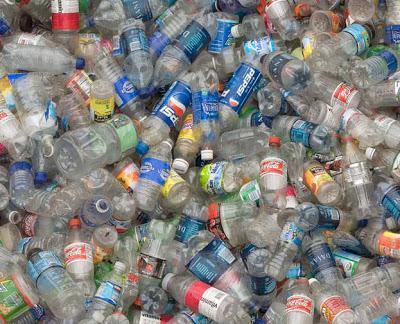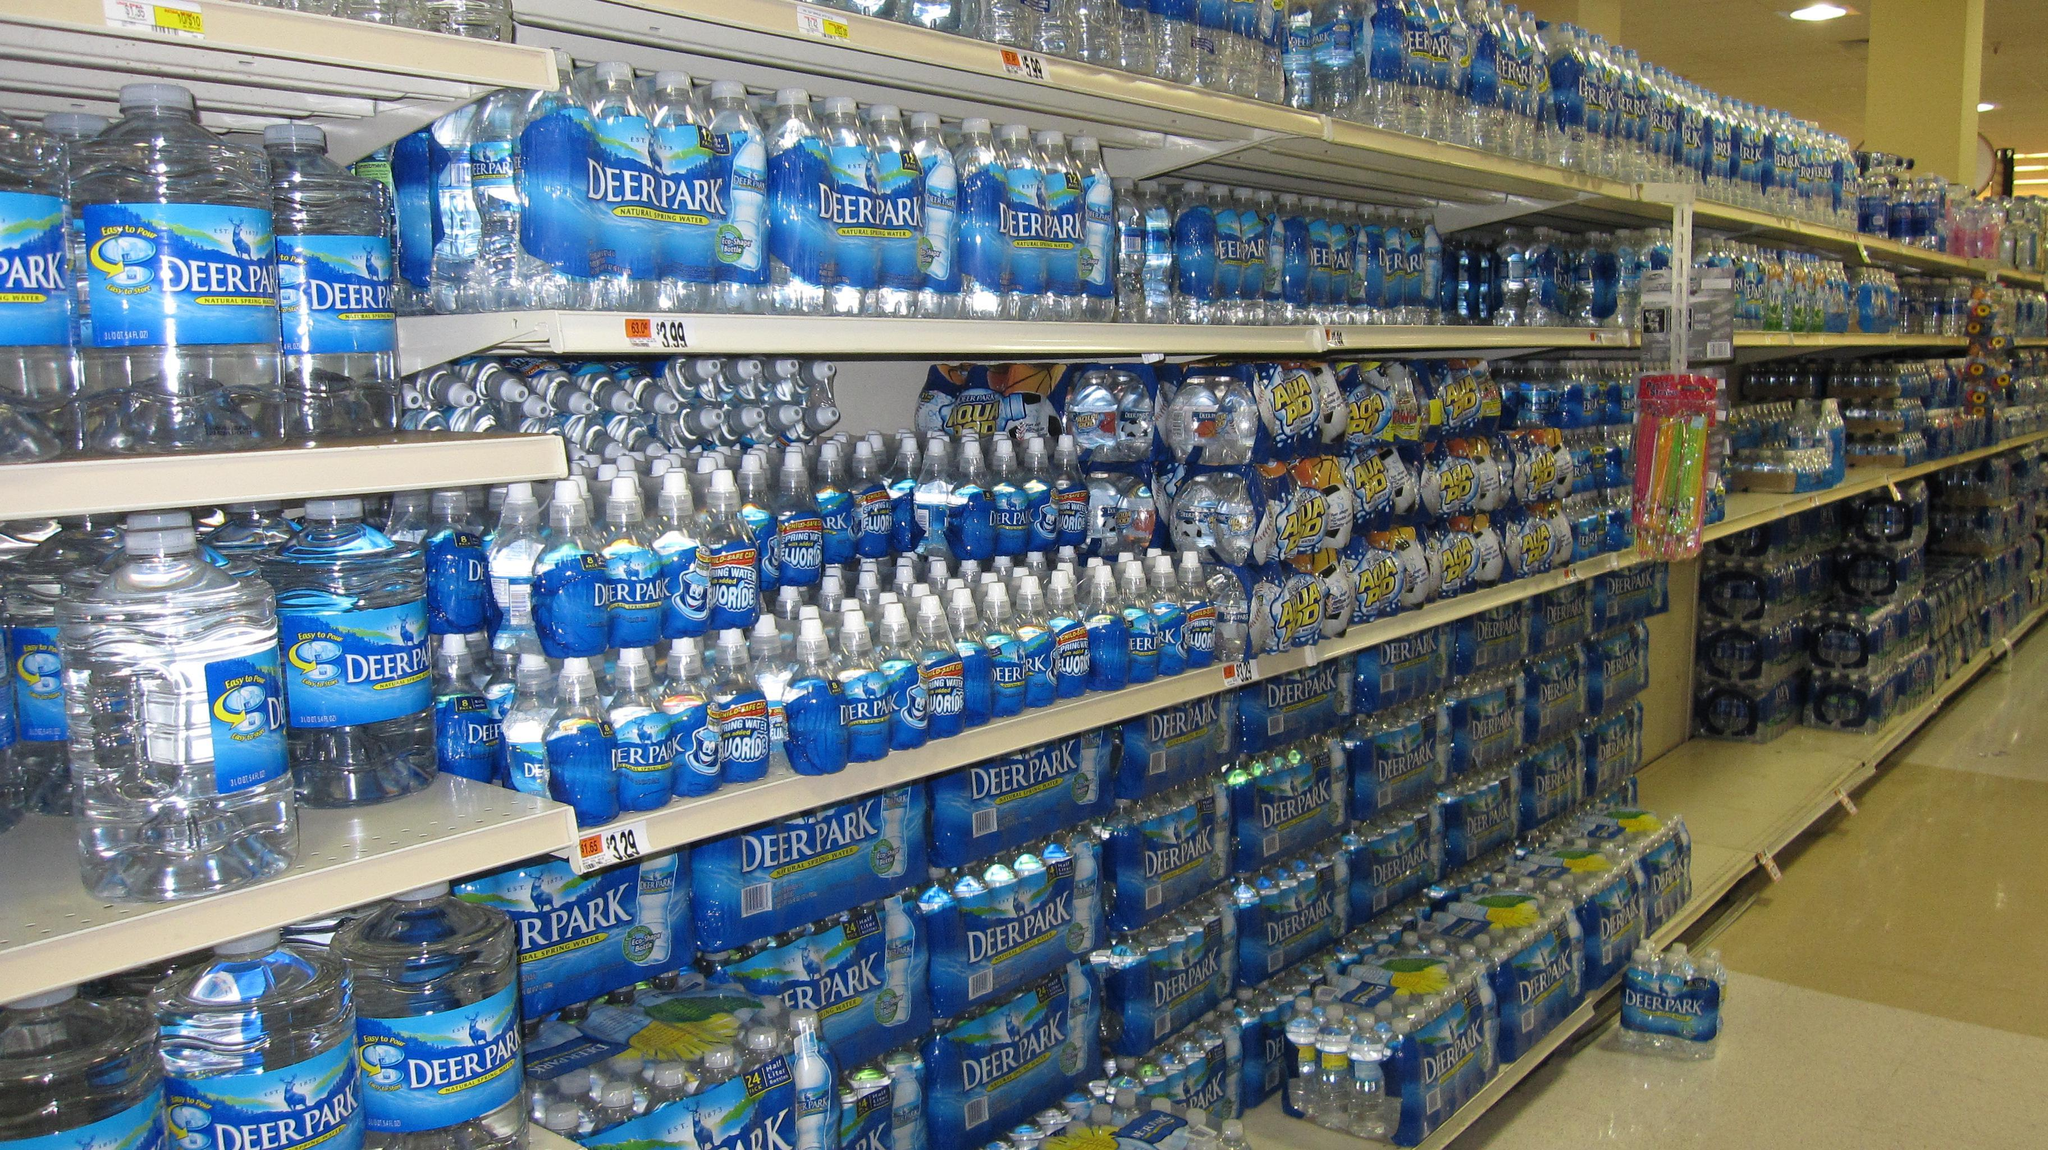The first image is the image on the left, the second image is the image on the right. Evaluate the accuracy of this statement regarding the images: "In the image on the right the water bottles are stacked on shelves.". Is it true? Answer yes or no. Yes. 